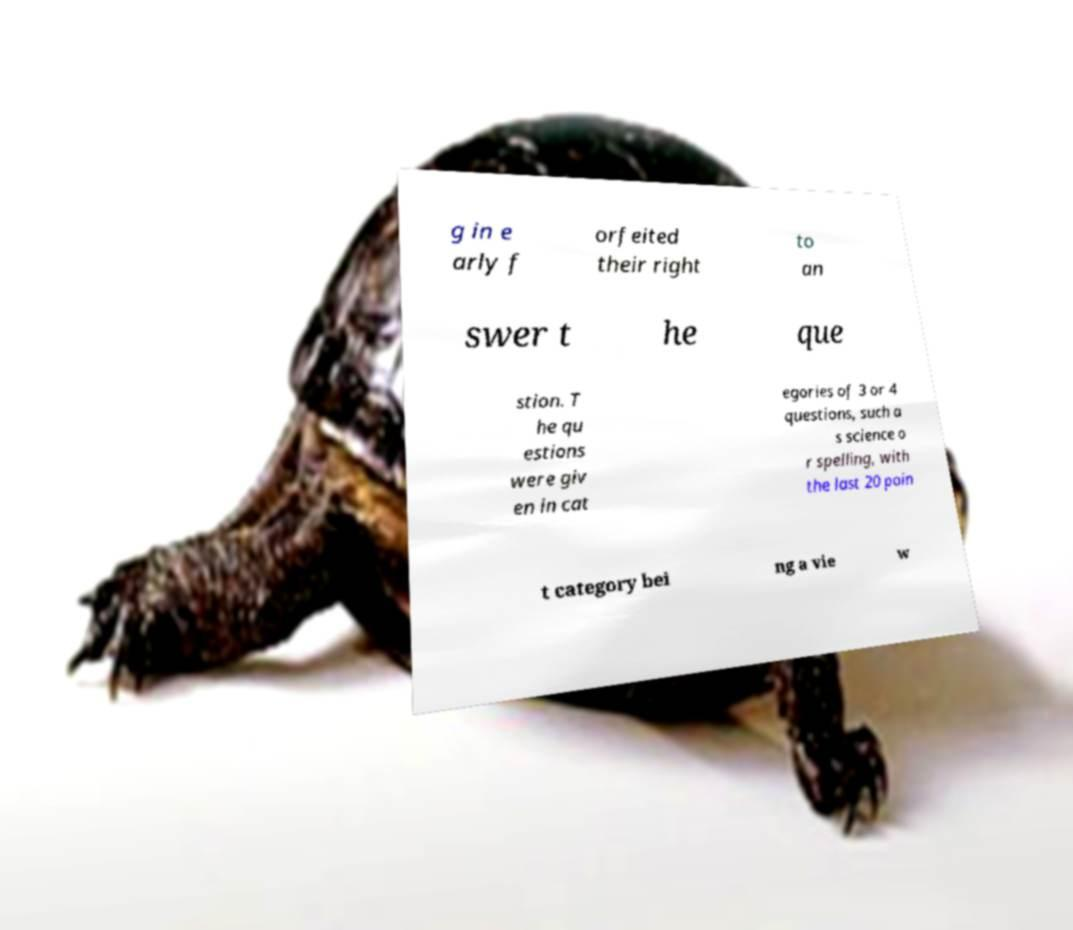Please identify and transcribe the text found in this image. g in e arly f orfeited their right to an swer t he que stion. T he qu estions were giv en in cat egories of 3 or 4 questions, such a s science o r spelling, with the last 20 poin t category bei ng a vie w 